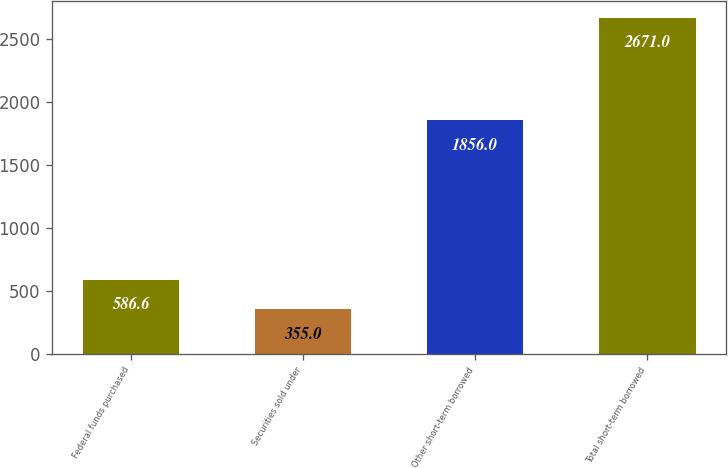Convert chart. <chart><loc_0><loc_0><loc_500><loc_500><bar_chart><fcel>Federal funds purchased<fcel>Securities sold under<fcel>Other short-term borrowed<fcel>Total short-term borrowed<nl><fcel>586.6<fcel>355<fcel>1856<fcel>2671<nl></chart> 